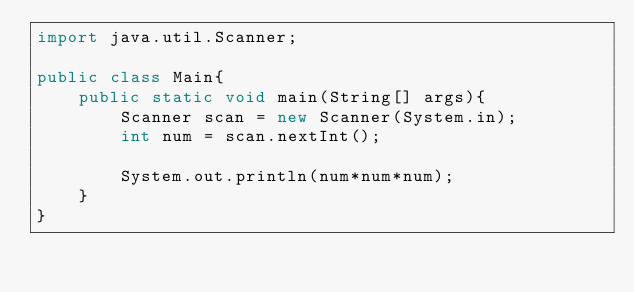Convert code to text. <code><loc_0><loc_0><loc_500><loc_500><_Java_>import java.util.Scanner;

public class Main{
    public static void main(String[] args){
        Scanner scan = new Scanner(System.in);
        int num = scan.nextInt();
        
        System.out.println(num*num*num);
    }
}
</code> 